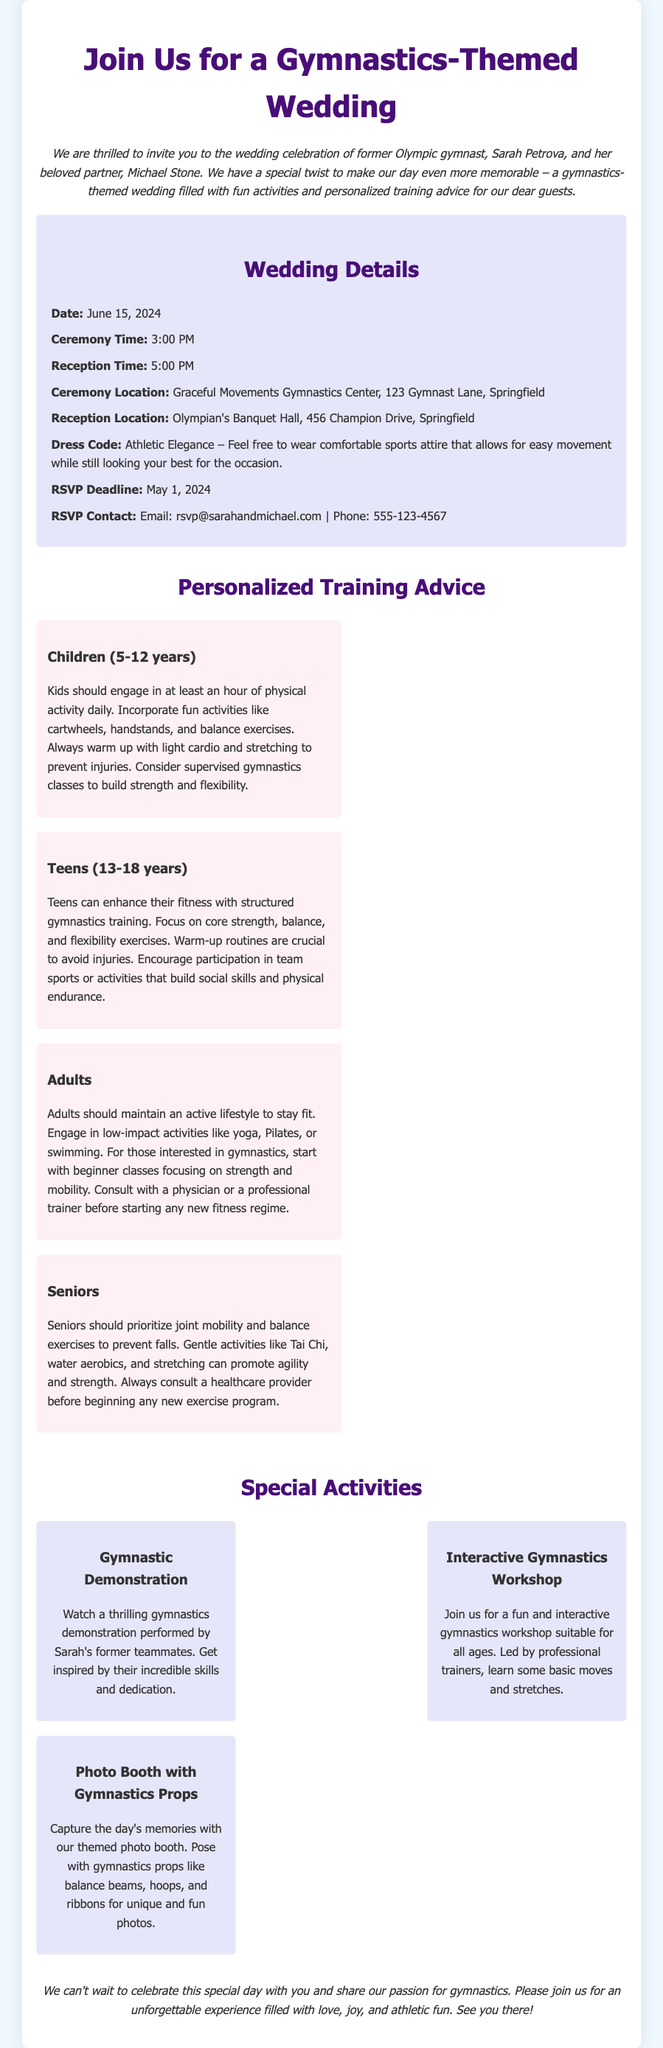what is the wedding date? The wedding date is clearly stated in the document under "Wedding Details."
Answer: June 15, 2024 what is the ceremony time? The ceremony time can be found in the "Wedding Details" section.
Answer: 3:00 PM who are the couple getting married? The document introduces the couple in the introductory paragraph.
Answer: Sarah Petrova and Michael Stone what should guests wear? The dress code is specified in the "Wedding Details" section.
Answer: Athletic Elegance which location hosts the reception? The reception location is found in the "Wedding Details" area.
Answer: Olympian's Banquet Hall, 456 Champion Drive, Springfield what type of activities will be at the wedding? The document lists various activities under "Special Activities."
Answer: Gymnastic Demonstration, Interactive Gymnastics Workshop, Photo Booth with Gymnastics Props what age group receives personalized training advice focused on balance exercises? The personalized training advice section specifies this information for teens.
Answer: Teens (13-18 years) how many hours of physical activity should kids engage in daily? This information is available in the advice section for children.
Answer: At least an hour 